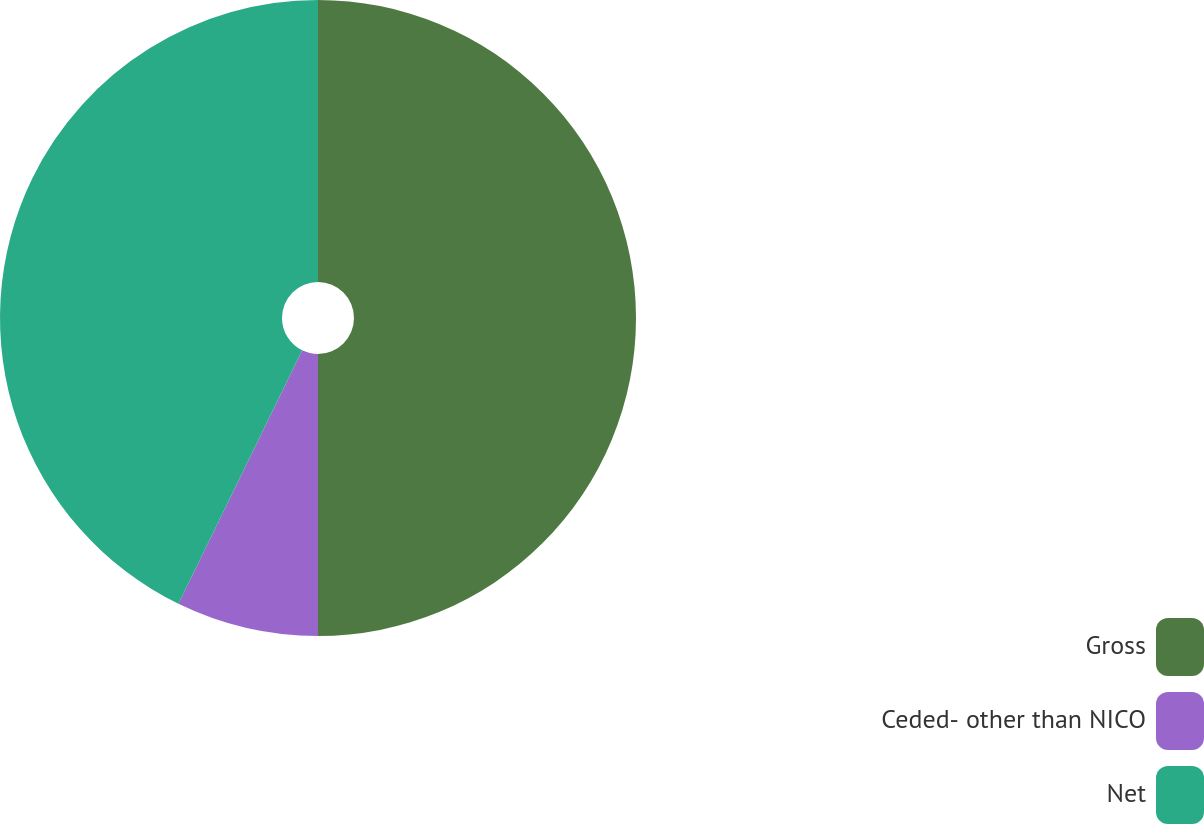Convert chart. <chart><loc_0><loc_0><loc_500><loc_500><pie_chart><fcel>Gross<fcel>Ceded- other than NICO<fcel>Net<nl><fcel>50.0%<fcel>7.23%<fcel>42.77%<nl></chart> 